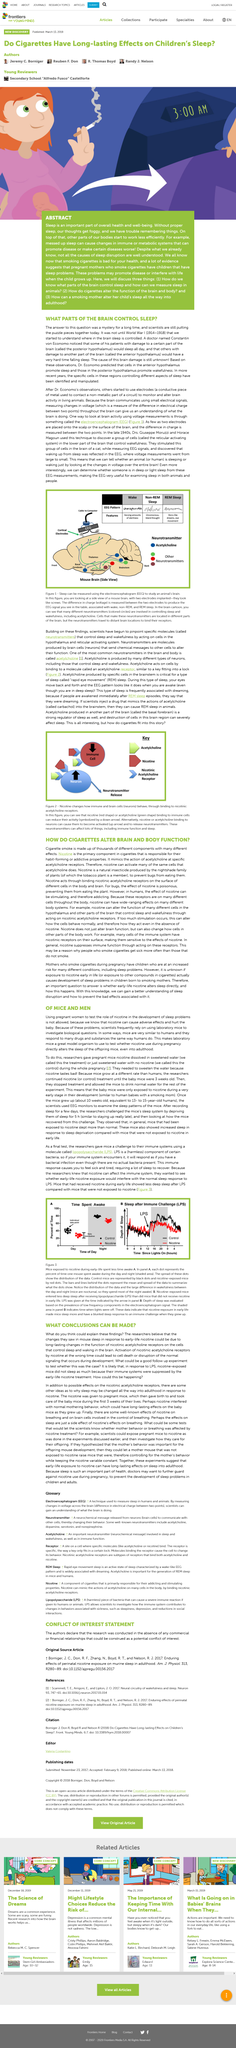Mention a couple of crucial points in this snapshot. The research study aimed to investigate the effects of nicotine on the development of neurons in the brain. The study found that activation of nicotinic acetylcholine receptors by nicotine at the wrong time could lead to cell death or disruption of normal signaling during development. These findings highlight the importance of proper timing in nicotine exposure and its potential impact on brain development. Mice are widely used in laboratories for testing due to their numerous similarities with humans, including their ability to respond to drugs and substances in a similar manner. The research examined the impact of early-life nicotine exposure on mouse sleep patterns and the long-lasting effects on the brain's receptor function and sleep-waking regulation. It was not until World War 1 (1914-1918) that they started to understand where in the brain sleep is controlled. The article titled 'What Conclusions Can Be Made?' investigated the use of mice in research and the conclusions that can be drawn from the results obtained from such studies. 